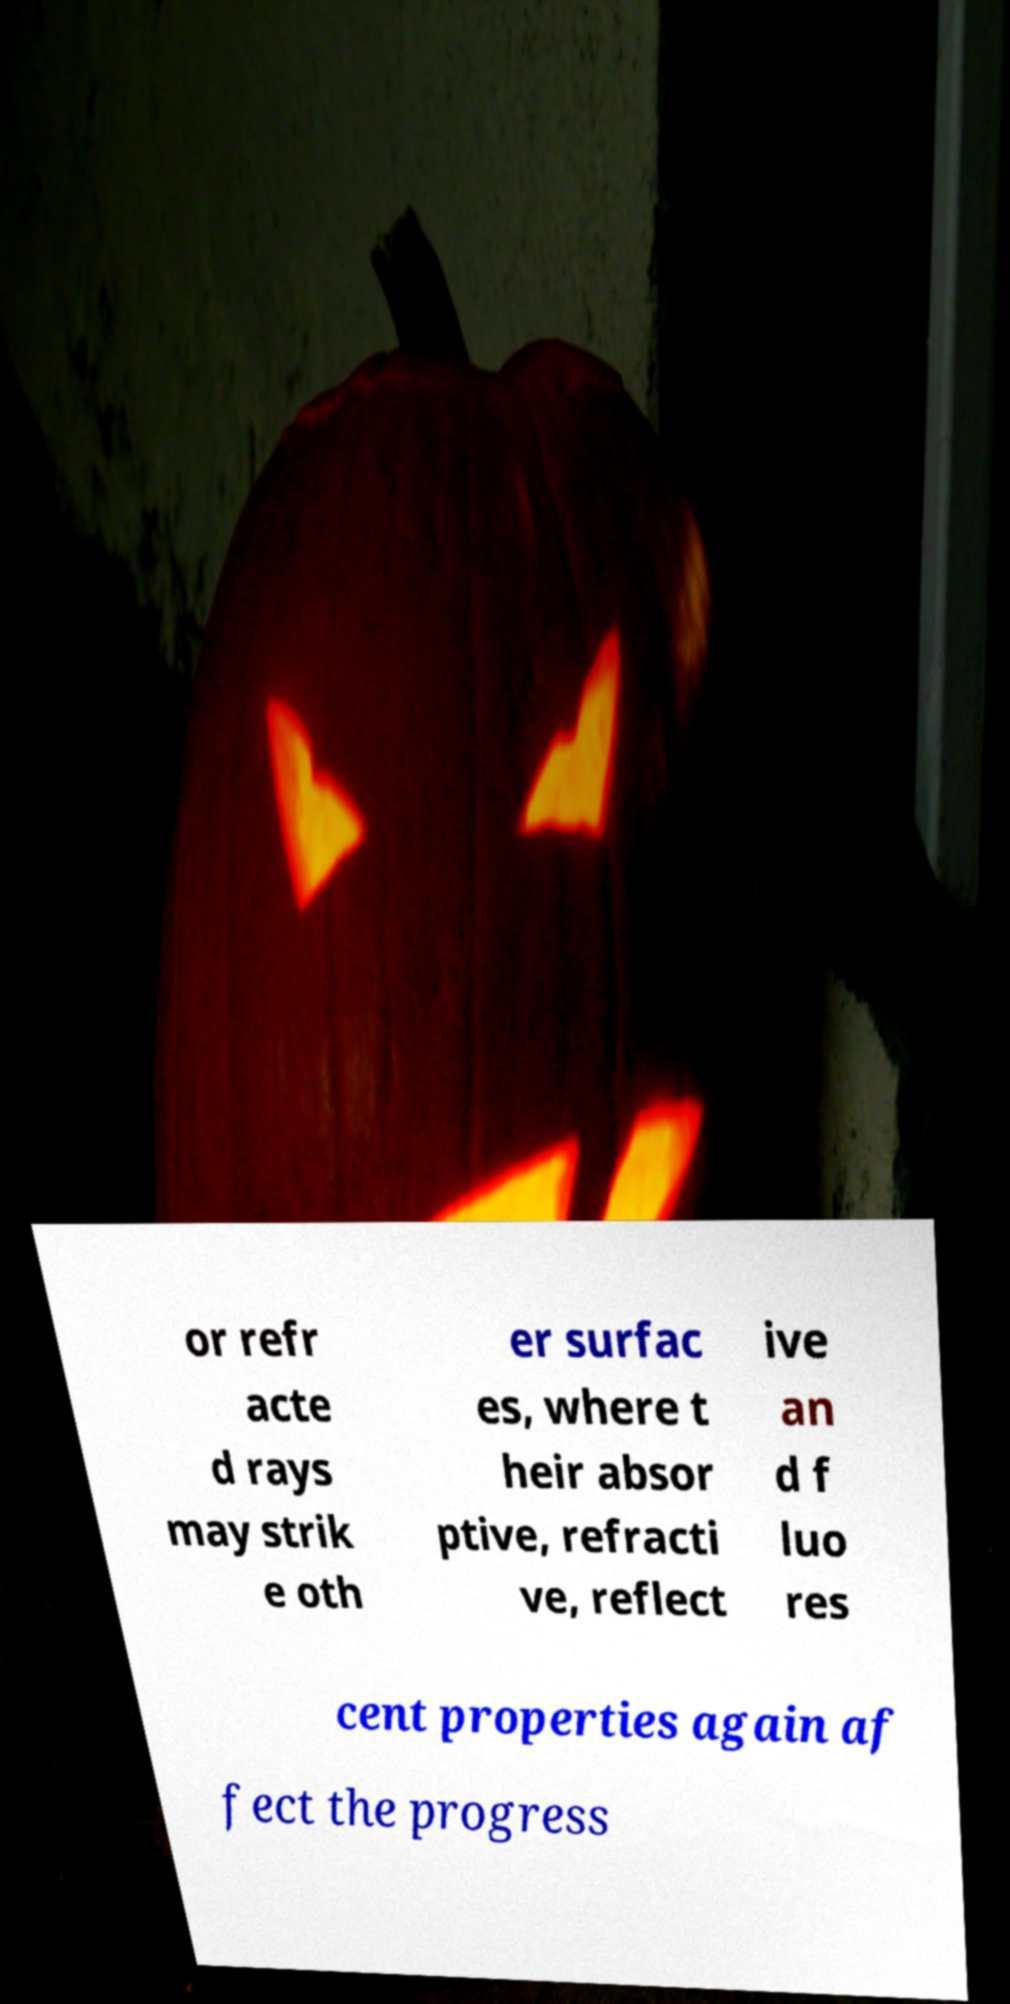There's text embedded in this image that I need extracted. Can you transcribe it verbatim? or refr acte d rays may strik e oth er surfac es, where t heir absor ptive, refracti ve, reflect ive an d f luo res cent properties again af fect the progress 